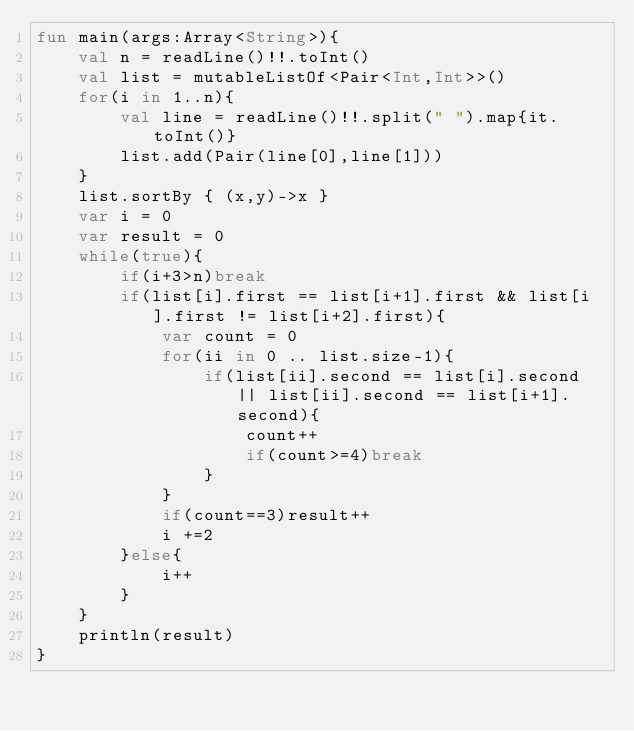Convert code to text. <code><loc_0><loc_0><loc_500><loc_500><_Kotlin_>fun main(args:Array<String>){
    val n = readLine()!!.toInt()
    val list = mutableListOf<Pair<Int,Int>>()
    for(i in 1..n){
        val line = readLine()!!.split(" ").map{it.toInt()}
        list.add(Pair(line[0],line[1]))
    }
    list.sortBy { (x,y)->x }
    var i = 0
    var result = 0
    while(true){
        if(i+3>n)break
        if(list[i].first == list[i+1].first && list[i].first != list[i+2].first){
            var count = 0
            for(ii in 0 .. list.size-1){
                if(list[ii].second == list[i].second || list[ii].second == list[i+1].second){
                    count++
                    if(count>=4)break
                }
            }
            if(count==3)result++
            i +=2
        }else{
            i++
        }
    }
    println(result)
}</code> 